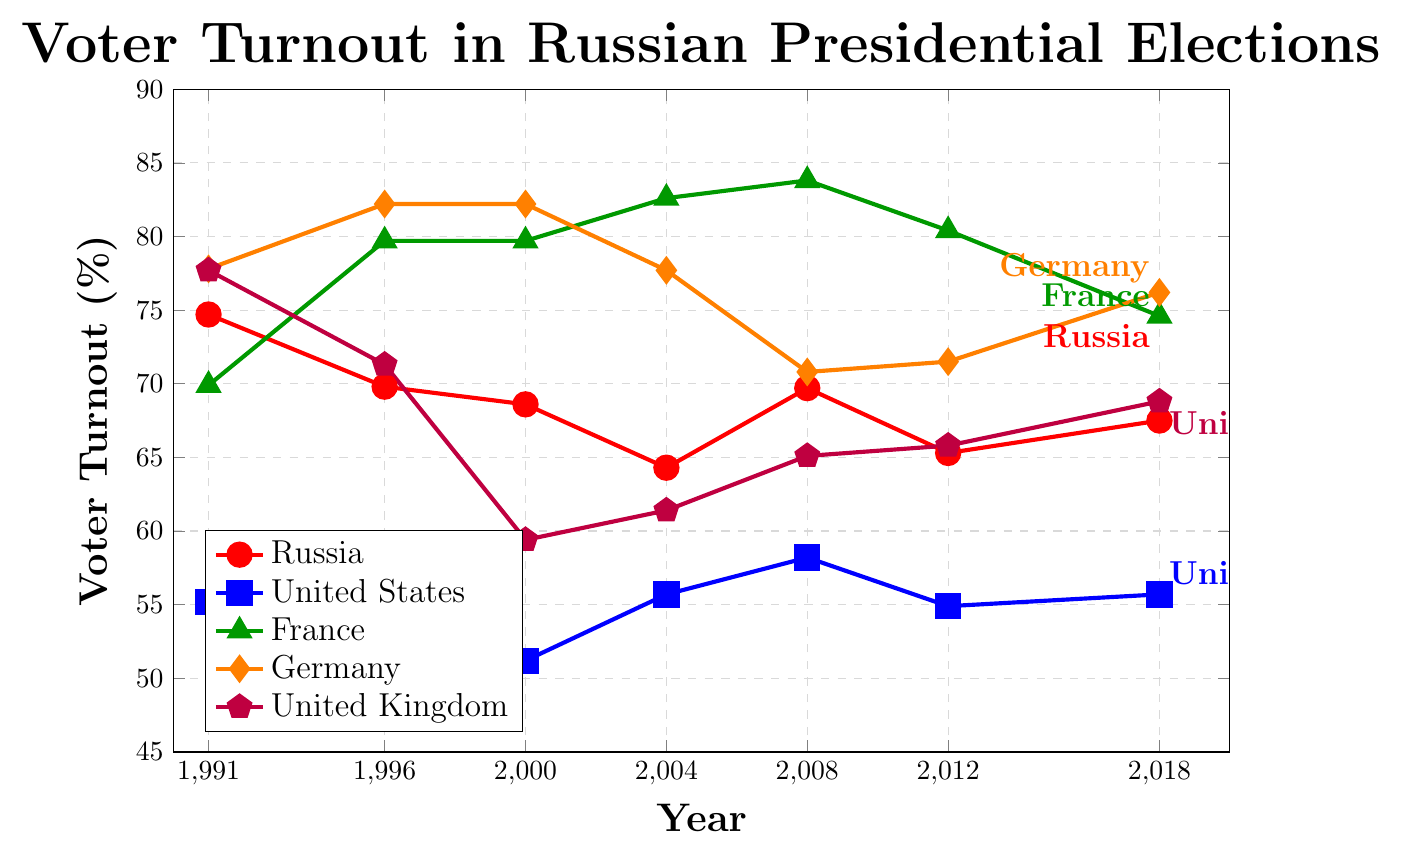Which country had the highest voter turnout in 2008? Look at the data points for 2008. Germany has the highest voter turnout at 70.8%.
Answer: Germany Has Russia’s voter turnout increased or decreased from 1991 to 2018? Identify the voter turnout for Russia in 1991 and 2018. In 1991, it was 74.7%, and in 2018, it was 67.5%, indicating a decrease.
Answer: Decreased What is the difference between the highest and lowest voter turnout in the United States? Find the maximum and minimum turnout values in the United States column. The highest voter turnout is 58.2% in 2008, and the lowest is 49.0% in 1996. The difference is 58.2% - 49.0% = 9.2%.
Answer: 9.2% Which country consistently had the lowest voter turnout from 1991 to 2018? Compare the data across all countries for each year. The United States consistently has the lowest voter turnout in all given years.
Answer: United States How does the voter turnout trend in Germany compare to that in the United Kingdom from 2008 to 2018? Examine the data for Germany and the United Kingdom for the years 2008, 2012, and 2018. Germany's turnout increased from 70.8% to 71.5% and then 76.2%, while the United Kingdom's increased from 65.1% to 65.8% and then 68.8%. Both countries show an increasing trend, but Germany shows a higher increase.
Answer: Both increased; Germany showed a higher increase In which year did France have the highest voter turnout? Look at the voter turnout data for France. The highest turnout is in 2008 at 83.8%.
Answer: 2008 Considering all the data points from 1991 to 2018, which country has the most stable voter turnout? Evaluate the range for each country. Germany's voter turnout varies the least, between 70.8% and 82.2%.
Answer: Germany How many times did the voter turnout in Russia fall below 70% between 1991 and 2018? Check the data for Russia from 1991 to 2018. The turnout fell below 70% in 1996, 2000, 2004, 2012, and 2018, a total of 5 times.
Answer: 5 times 